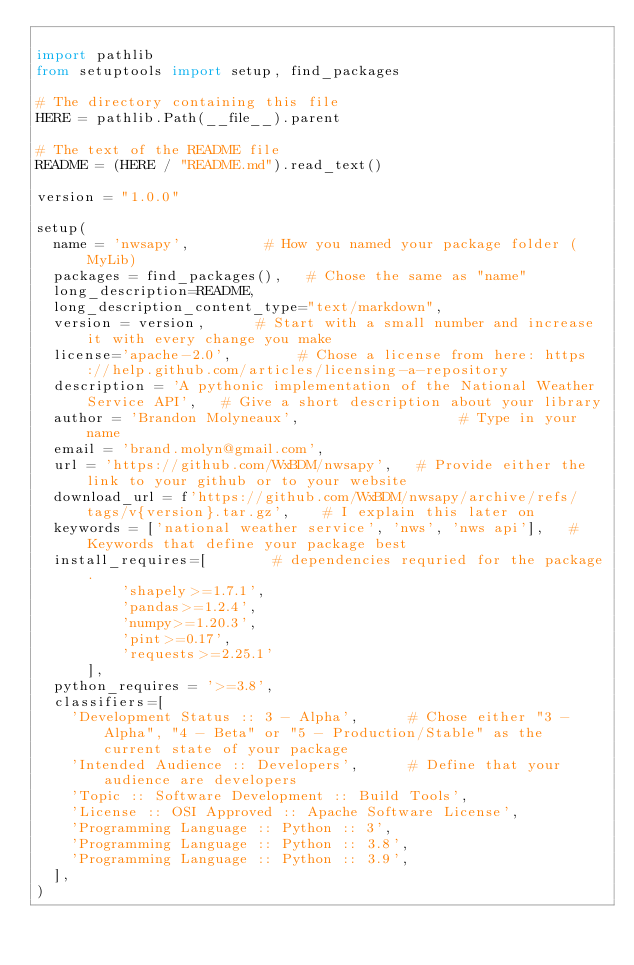Convert code to text. <code><loc_0><loc_0><loc_500><loc_500><_Python_>
import pathlib
from setuptools import setup, find_packages

# The directory containing this file
HERE = pathlib.Path(__file__).parent

# The text of the README file
README = (HERE / "README.md").read_text()

version = "1.0.0"

setup(
  name = 'nwsapy',         # How you named your package folder (MyLib)
  packages = find_packages(),   # Chose the same as "name"
  long_description=README,
  long_description_content_type="text/markdown",
  version = version,      # Start with a small number and increase it with every change you make
  license='apache-2.0',        # Chose a license from here: https://help.github.com/articles/licensing-a-repository
  description = 'A pythonic implementation of the National Weather Service API',   # Give a short description about your library
  author = 'Brandon Molyneaux',                   # Type in your name
  email = 'brand.molyn@gmail.com',
  url = 'https://github.com/WxBDM/nwsapy',   # Provide either the link to your github or to your website
  download_url = f'https://github.com/WxBDM/nwsapy/archive/refs/tags/v{version}.tar.gz',    # I explain this later on
  keywords = ['national weather service', 'nws', 'nws api'],   # Keywords that define your package best
  install_requires=[        # dependencies requried for the package.
          'shapely>=1.7.1',
          'pandas>=1.2.4',
          'numpy>=1.20.3',
          'pint>=0.17',
          'requests>=2.25.1'
      ],
  python_requires = '>=3.8',
  classifiers=[
    'Development Status :: 3 - Alpha',      # Chose either "3 - Alpha", "4 - Beta" or "5 - Production/Stable" as the current state of your package
    'Intended Audience :: Developers',      # Define that your audience are developers
    'Topic :: Software Development :: Build Tools',
    'License :: OSI Approved :: Apache Software License',
    'Programming Language :: Python :: 3', 
    'Programming Language :: Python :: 3.8',
    'Programming Language :: Python :: 3.9',
  ],
)
</code> 